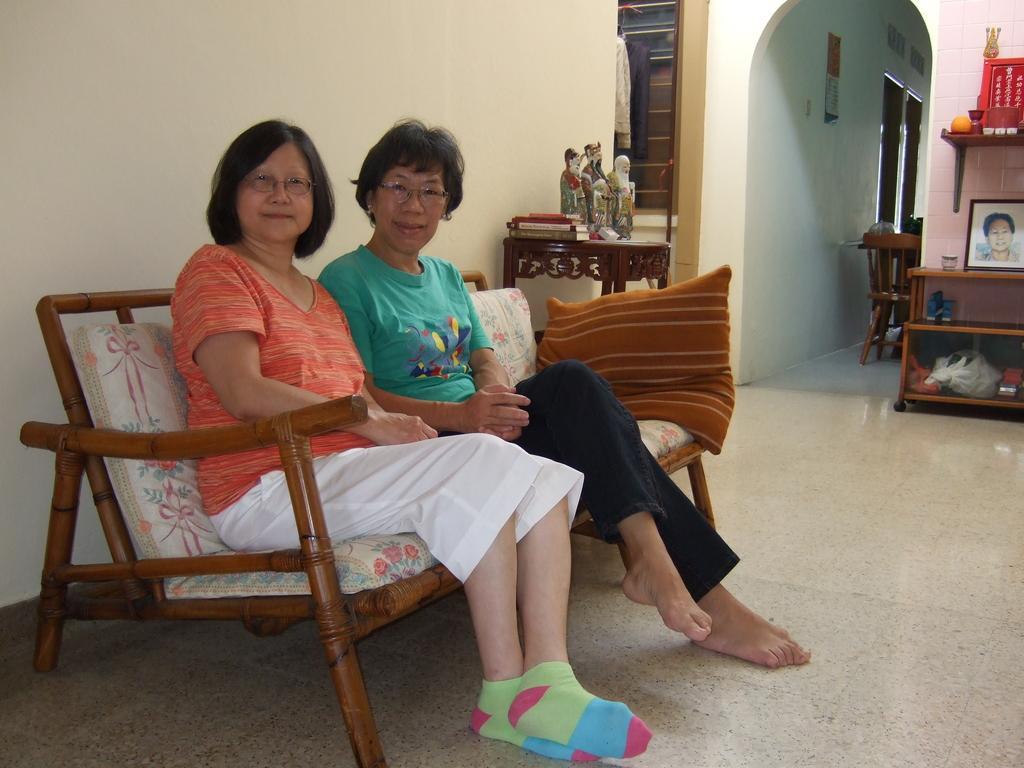In one or two sentences, can you explain what this image depicts? On the left side of the image I can see the sofa, pillows, books, toys and two people are sitting. On the right side of the image I can see photo frames, cupboard and some other objects. In the background, I can see photo frames and doors. 